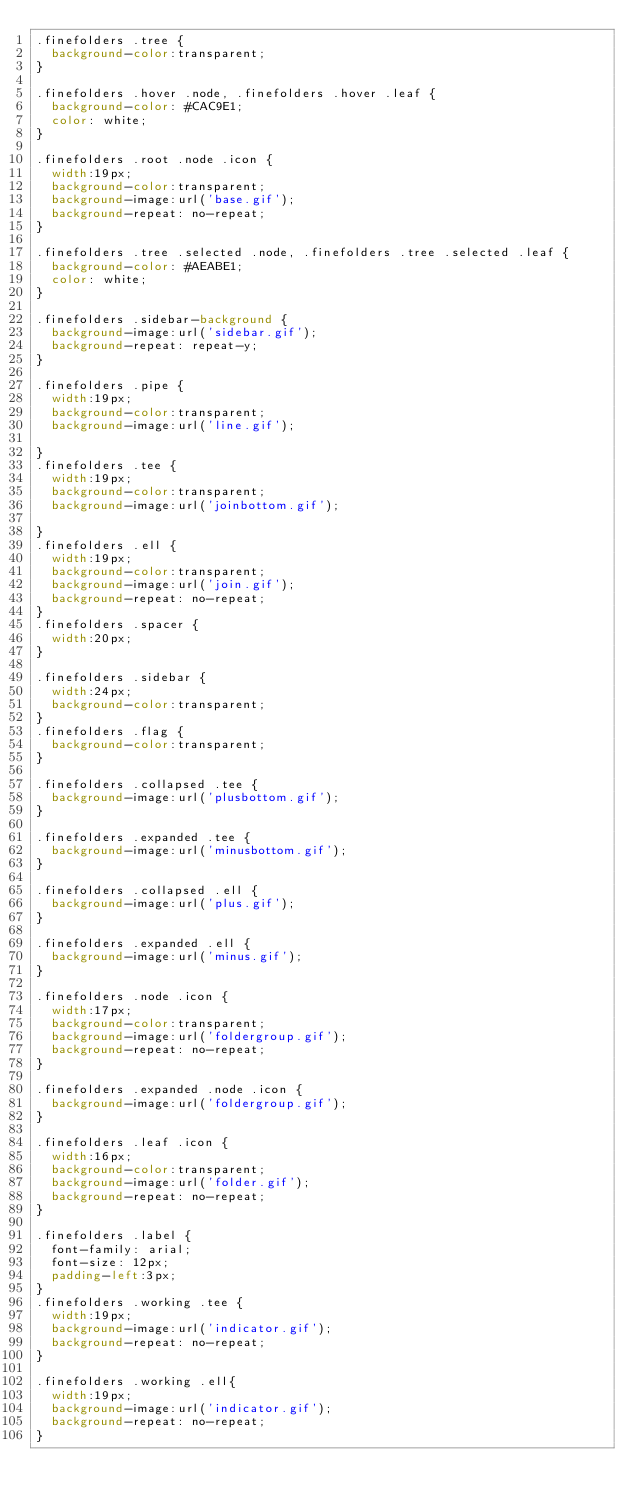Convert code to text. <code><loc_0><loc_0><loc_500><loc_500><_CSS_>.finefolders .tree {
	background-color:transparent;
}

.finefolders .hover .node, .finefolders .hover .leaf { 
	background-color: #CAC9E1; 
	color: white;	
}

.finefolders .root .node .icon {
	width:19px;
	background-color:transparent;
	background-image:url('base.gif');
	background-repeat: no-repeat;
}

.finefolders .tree .selected .node, .finefolders .tree .selected .leaf {
	background-color: #AEABE1;
	color: white;
}

.finefolders .sidebar-background {
	background-image:url('sidebar.gif');
	background-repeat: repeat-y;
}

.finefolders .pipe {
	width:19px;
	background-color:transparent;
	background-image:url('line.gif');

}
.finefolders .tee {
	width:19px;
	background-color:transparent;
	background-image:url('joinbottom.gif');

}
.finefolders .ell {
	width:19px;
	background-color:transparent;
	background-image:url('join.gif');
	background-repeat: no-repeat;
}
.finefolders .spacer {
	width:20px;
}

.finefolders .sidebar {
	width:24px;
	background-color:transparent;
}
.finefolders .flag {
	background-color:transparent;
}

.finefolders .collapsed .tee {
	background-image:url('plusbottom.gif');
}

.finefolders .expanded .tee {
	background-image:url('minusbottom.gif');
}

.finefolders .collapsed .ell {
	background-image:url('plus.gif');
}

.finefolders .expanded .ell {
	background-image:url('minus.gif');
}

.finefolders .node .icon {
	width:17px;
	background-color:transparent;
	background-image:url('foldergroup.gif');
	background-repeat: no-repeat;
}

.finefolders .expanded .node .icon {
	background-image:url('foldergroup.gif');
}

.finefolders .leaf .icon {
	width:16px;
	background-color:transparent;
	background-image:url('folder.gif');
	background-repeat: no-repeat;
}

.finefolders .label {
	font-family: arial;
	font-size: 12px;
	padding-left:3px;
}
.finefolders .working .tee {
	width:19px;
	background-image:url('indicator.gif');
	background-repeat: no-repeat;
}

.finefolders .working .ell{
	width:19px;
	background-image:url('indicator.gif');
	background-repeat: no-repeat;
}</code> 